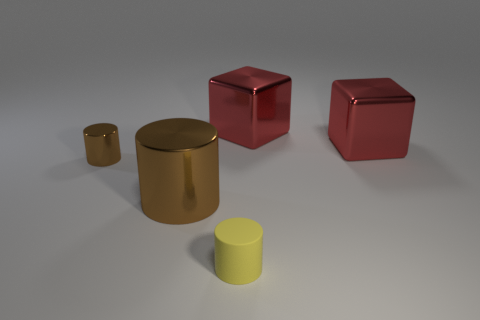Are there fewer yellow rubber objects that are behind the small brown cylinder than tiny brown things that are behind the large metal cylinder?
Your answer should be compact. Yes. There is a object to the left of the large object that is to the left of the small thing in front of the small shiny cylinder; how big is it?
Give a very brief answer. Small. What number of other things are there of the same material as the large brown cylinder
Offer a terse response. 3. Are there more brown cylinders than cylinders?
Your answer should be very brief. No. What material is the small cylinder that is on the right side of the small cylinder that is left of the cylinder that is in front of the large cylinder?
Your answer should be compact. Rubber. Is the big cylinder the same color as the tiny metal thing?
Provide a succinct answer. Yes. Is there a metal object of the same color as the large metal cylinder?
Make the answer very short. Yes. There is another object that is the same size as the yellow rubber object; what is its shape?
Provide a short and direct response. Cylinder. Is the number of brown objects less than the number of large objects?
Provide a succinct answer. Yes. How many other brown objects are the same size as the matte thing?
Keep it short and to the point. 1. 